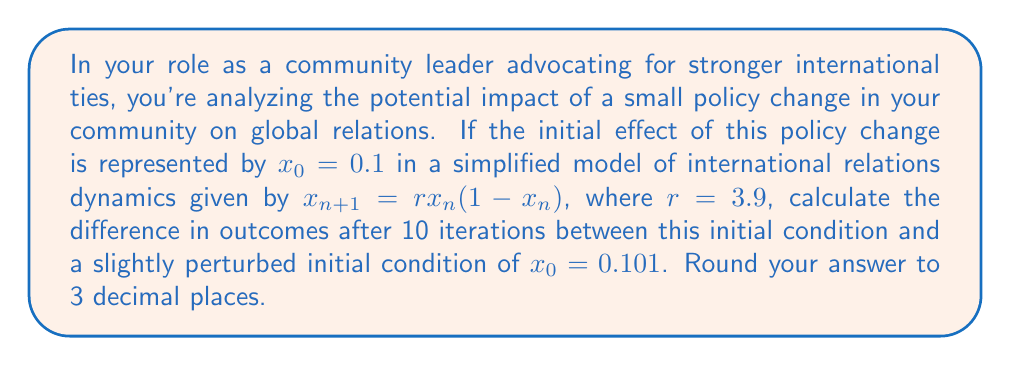Give your solution to this math problem. To solve this problem, we need to iterate the given function for both initial conditions and compare the results after 10 iterations. Let's break it down step-by-step:

1) The function is given by $x_{n+1} = rx_n(1-x_n)$ where $r = 3.9$

2) For the first initial condition, $x_0 = 0.1$:
   $x_1 = 3.9 * 0.1 * (1-0.1) = 0.351$
   $x_2 = 3.9 * 0.351 * (1-0.351) = 0.889$
   $x_3 = 3.9 * 0.889 * (1-0.889) = 0.385$
   ...
   (continuing this process for 10 iterations)
   $x_{10} = 0.836$

3) For the perturbed initial condition, $x_0 = 0.101$:
   $x_1 = 3.9 * 0.101 * (1-0.101) = 0.354$
   $x_2 = 3.9 * 0.354 * (1-0.354) = 0.892$
   $x_3 = 3.9 * 0.892 * (1-0.892) = 0.375$
   ...
   (continuing this process for 10 iterations)
   $x_{10} = 0.626$

4) The difference after 10 iterations is:
   $|0.836 - 0.626| = 0.210$

5) Rounding to 3 decimal places: 0.210

This demonstrates the butterfly effect in international relations, where a small change in initial conditions (0.001 difference in the initial policy impact) leads to a significant difference (0.210) after just 10 iterations of the model.
Answer: 0.210 